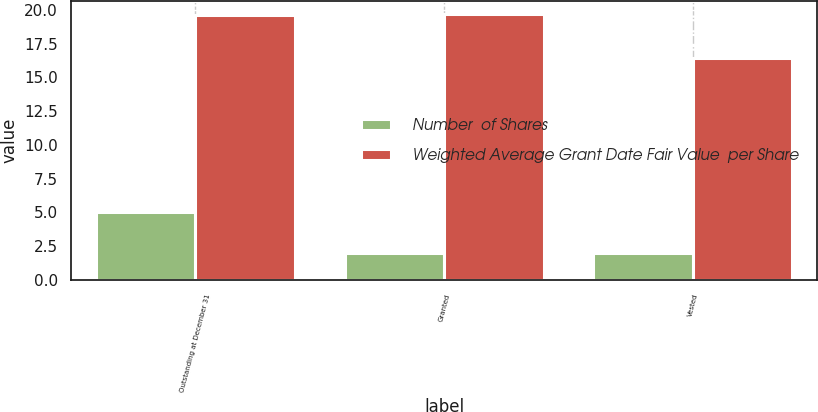<chart> <loc_0><loc_0><loc_500><loc_500><stacked_bar_chart><ecel><fcel>Outstanding at December 31<fcel>Granted<fcel>Vested<nl><fcel>Number  of Shares<fcel>5<fcel>2<fcel>2<nl><fcel>Weighted Average Grant Date Fair Value  per Share<fcel>19.64<fcel>19.66<fcel>16.44<nl></chart> 